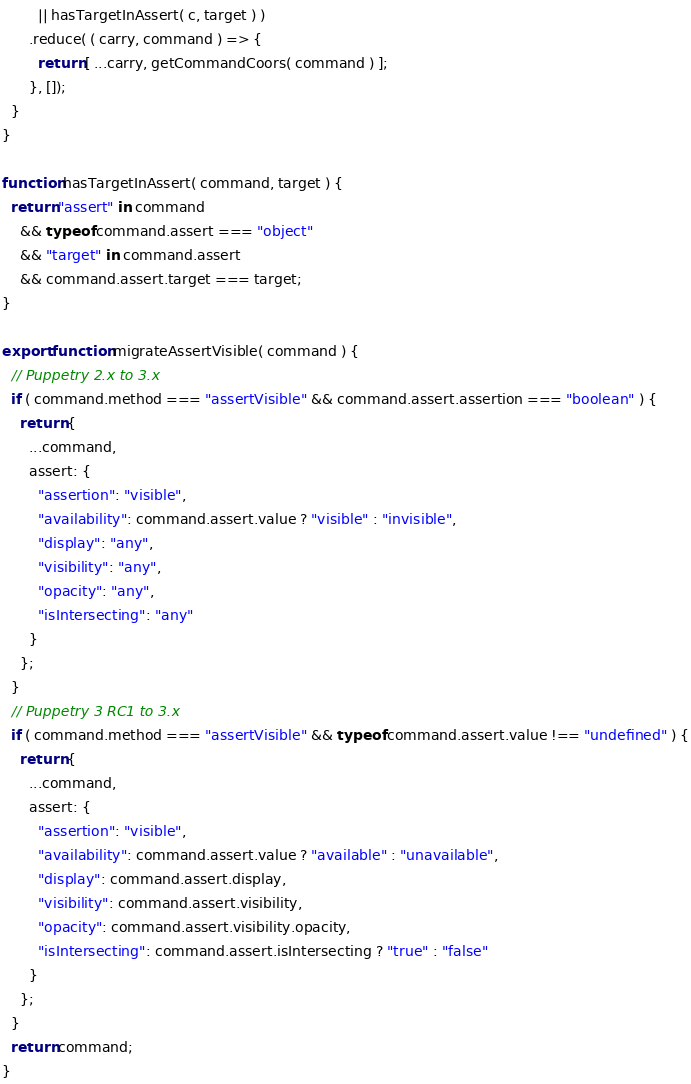<code> <loc_0><loc_0><loc_500><loc_500><_JavaScript_>        || hasTargetInAssert( c, target ) )
      .reduce( ( carry, command ) => {
        return [ ...carry, getCommandCoors( command ) ];
      }, []);
  }
}

function hasTargetInAssert( command, target ) {
  return "assert" in command
    && typeof command.assert === "object"
    && "target" in command.assert
    && command.assert.target === target;
}

export function migrateAssertVisible( command ) {
  // Puppetry 2.x to 3.x
  if ( command.method === "assertVisible" && command.assert.assertion === "boolean" ) {
    return {
      ...command,
      assert: {
        "assertion": "visible",
        "availability": command.assert.value ? "visible" : "invisible",
        "display": "any",
        "visibility": "any",
        "opacity": "any",
        "isIntersecting": "any"
      }
    };
  }
  // Puppetry 3 RC1 to 3.x
  if ( command.method === "assertVisible" && typeof command.assert.value !== "undefined" ) {
    return {
      ...command,
      assert: {
        "assertion": "visible",
        "availability": command.assert.value ? "available" : "unavailable",
        "display": command.assert.display,
        "visibility": command.assert.visibility,
        "opacity": command.assert.visibility.opacity,
        "isIntersecting": command.assert.isIntersecting ? "true" : "false"
      }
    };
  }
  return command;
}</code> 